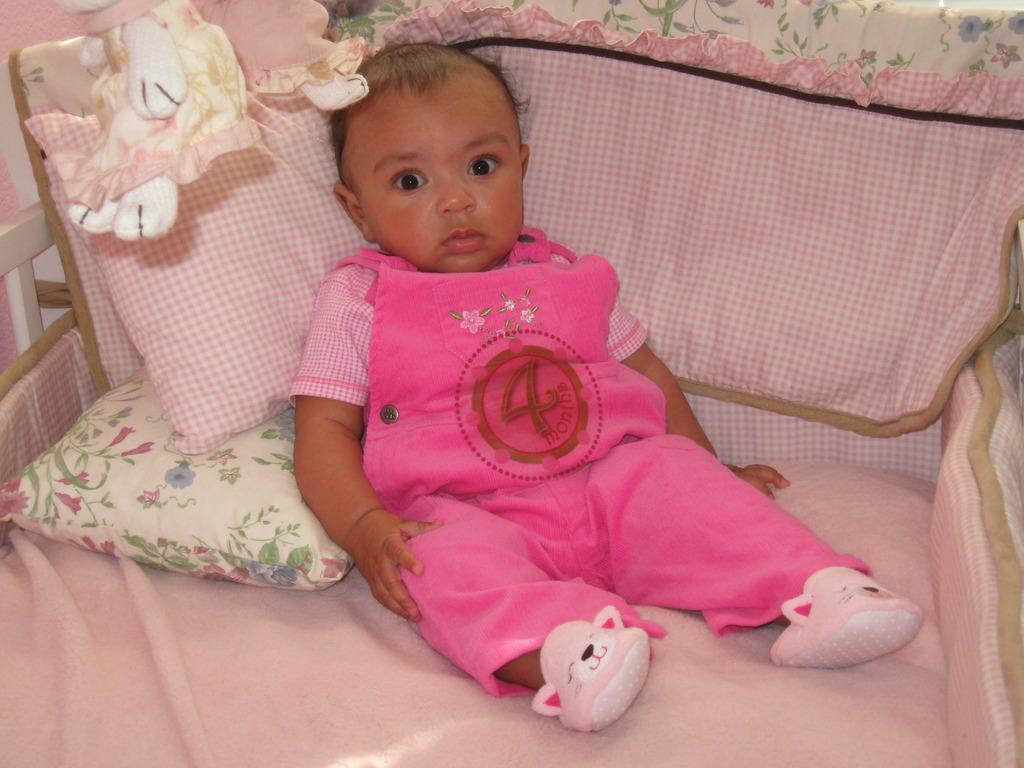Could you give a brief overview of what you see in this image? In this image I can see a baby visible on bed and I can see two pillows and a pink color bed sheet and baby wearing a pink color dress. 